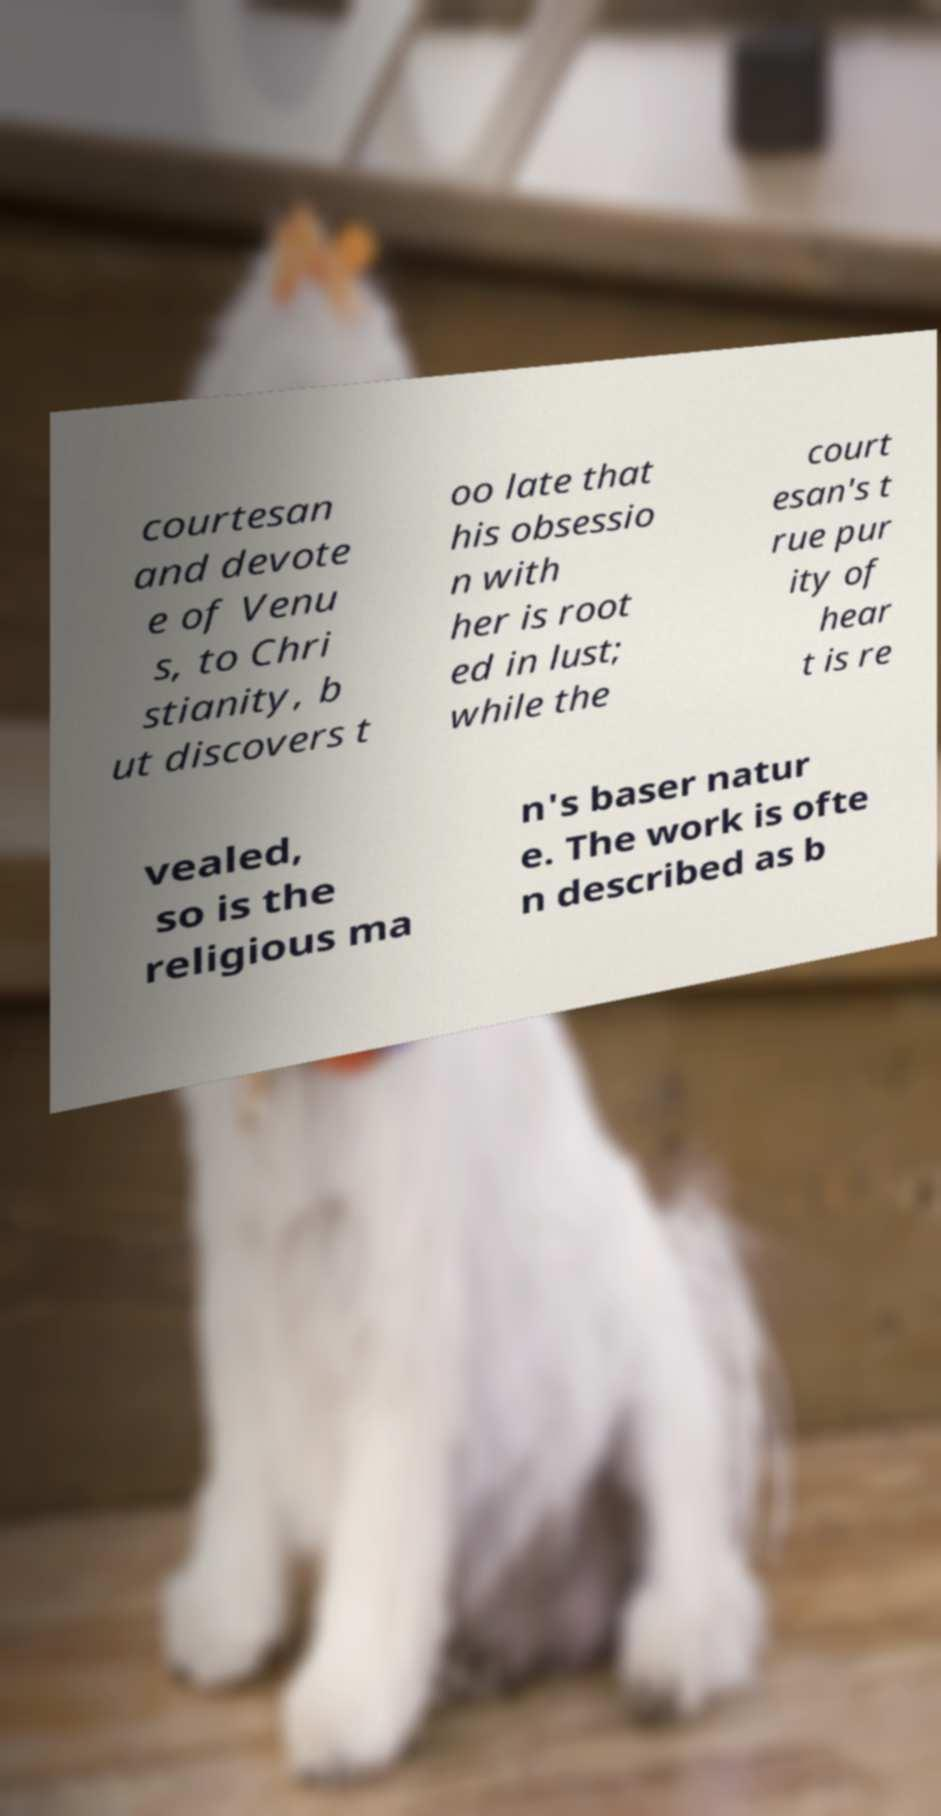I need the written content from this picture converted into text. Can you do that? courtesan and devote e of Venu s, to Chri stianity, b ut discovers t oo late that his obsessio n with her is root ed in lust; while the court esan's t rue pur ity of hear t is re vealed, so is the religious ma n's baser natur e. The work is ofte n described as b 